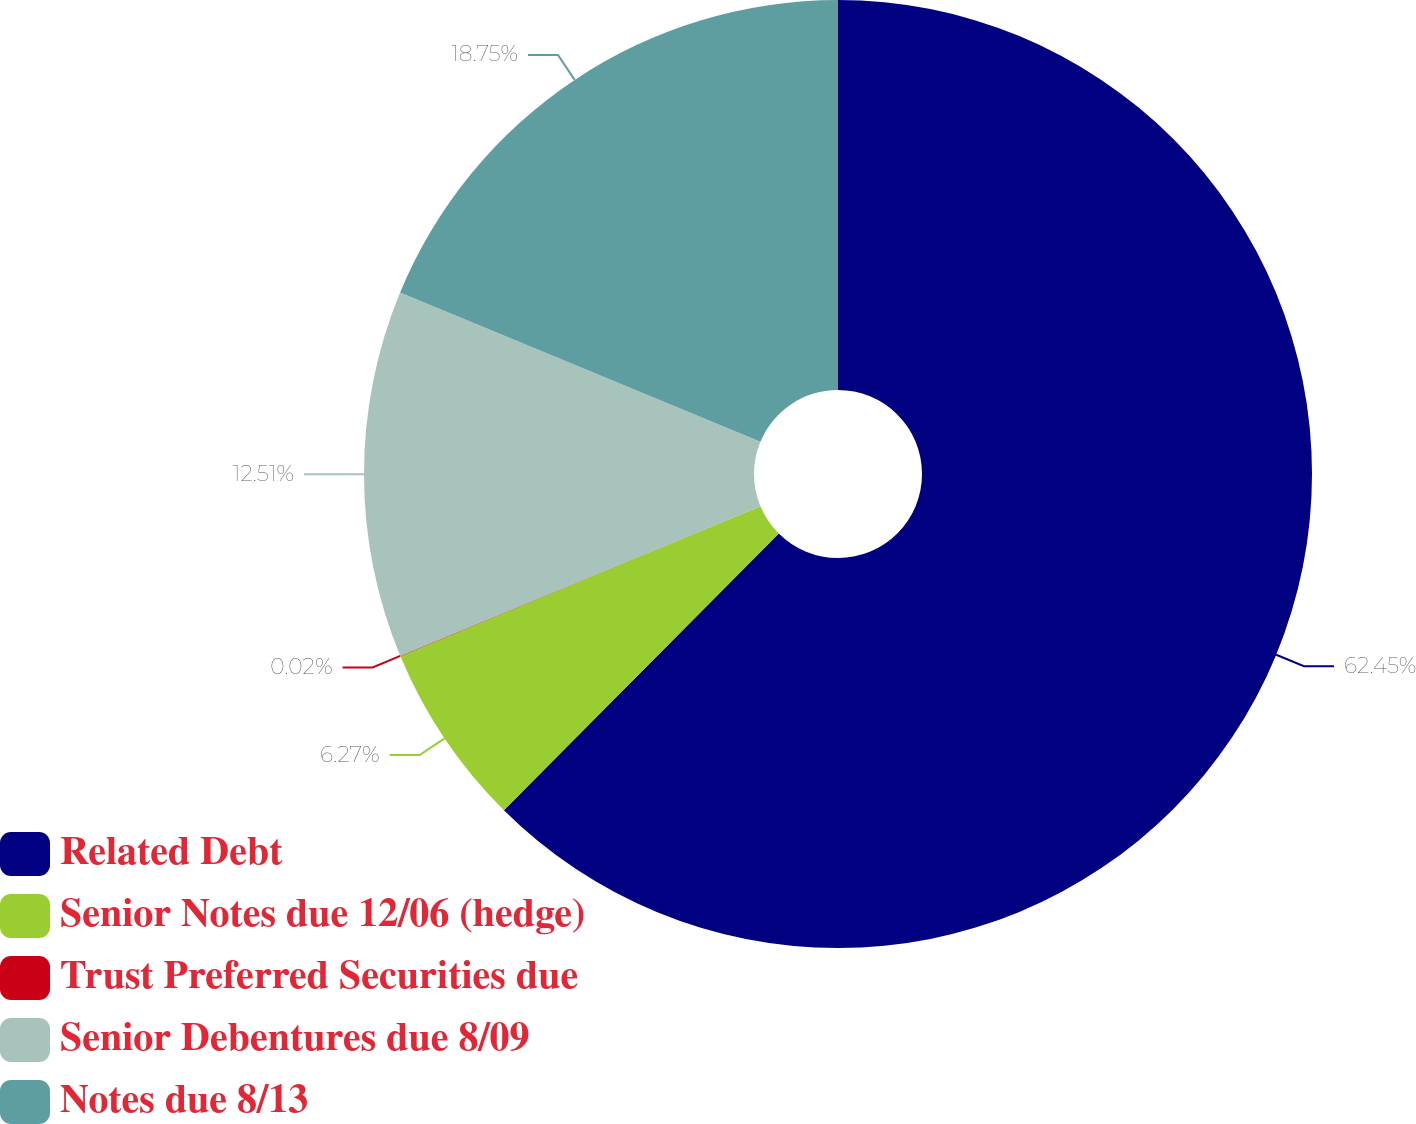Convert chart to OTSL. <chart><loc_0><loc_0><loc_500><loc_500><pie_chart><fcel>Related Debt<fcel>Senior Notes due 12/06 (hedge)<fcel>Trust Preferred Securities due<fcel>Senior Debentures due 8/09<fcel>Notes due 8/13<nl><fcel>62.45%<fcel>6.27%<fcel>0.02%<fcel>12.51%<fcel>18.75%<nl></chart> 